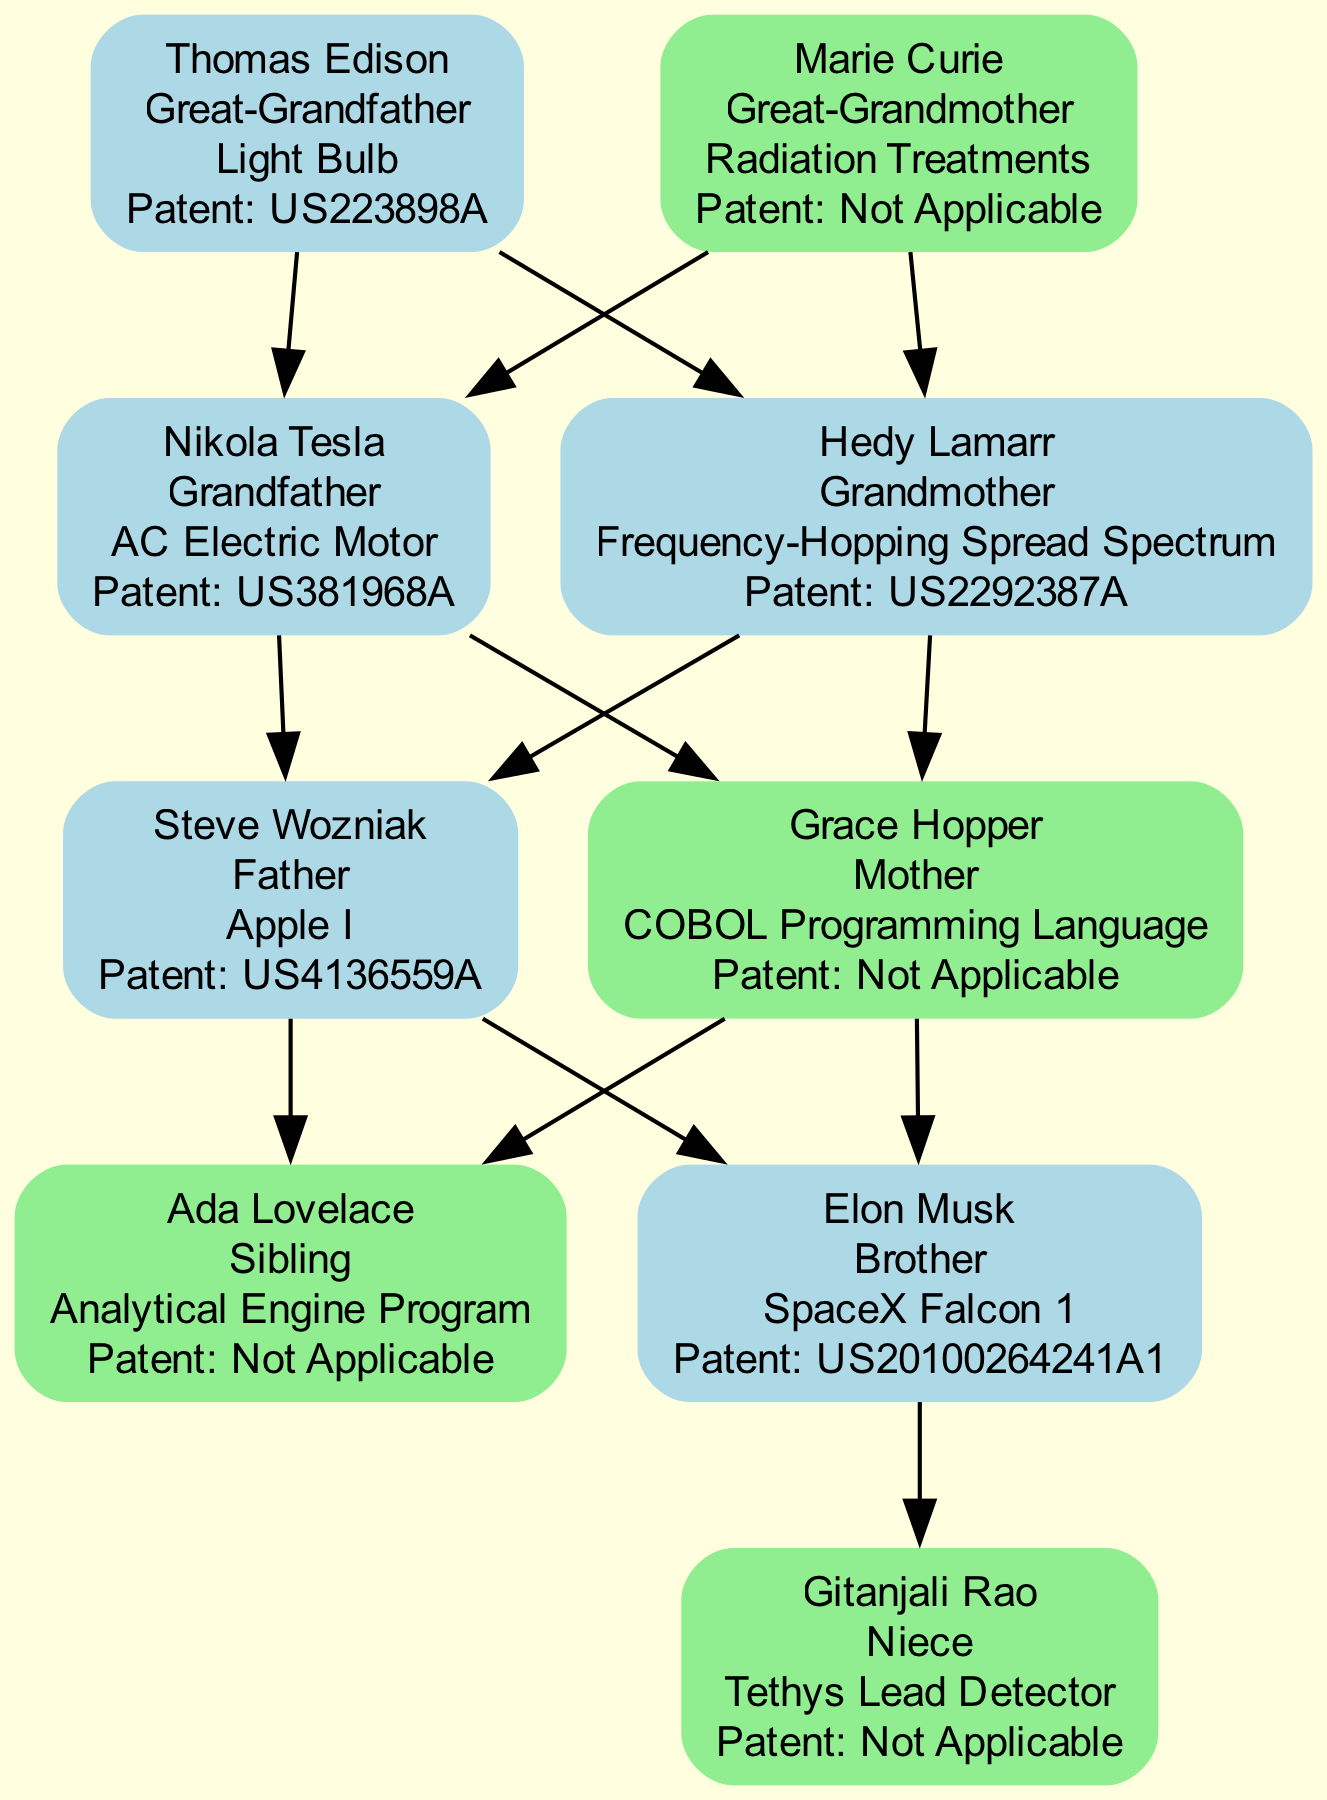What is the project of the Great-Grandfather? The Great-Grandfather's name is Thomas Edison, and he worked on the "Light Bulb" project.
Answer: Light Bulb Who is the Grandmother? The Grandmother in the diagram is Hedy Lamarr.
Answer: Hedy Lamarr How many patents does Grace Hopper have? Grace Hopper is listed as having "Not Applicable" for her patent, indicating she does not hold one.
Answer: Not Applicable Which project did Elon Musk work on? Elon Musk is noted for his project "SpaceX Falcon 1."
Answer: SpaceX Falcon 1 Who are the parents of Ada Lovelace? Ada Lovelace's parents are Steve Wozniak and Grace Hopper, as indicated by the connecting edges in the diagram.
Answer: Steve Wozniak and Grace Hopper Who is the only family member with a project related to radiation? The family member associated with radiation is the Great-Grandmother, Marie Curie, who worked on "Radiation Treatments."
Answer: Marie Curie How many grandchildren are there in total? In the diagram, there are two grandchildren: Steve Wozniak and Grace Hopper.
Answer: 2 What is the relationship between Gitanjali Rao and Elon Musk? Gitanjali Rao is the niece of Elon Musk as indicated by the diagram's structure connecting them through family relationships.
Answer: Niece Name one patent held by Nikola Tesla. Nikola Tesla holds the patent "US381968A" for his project "AC Electric Motor."
Answer: US381968A 